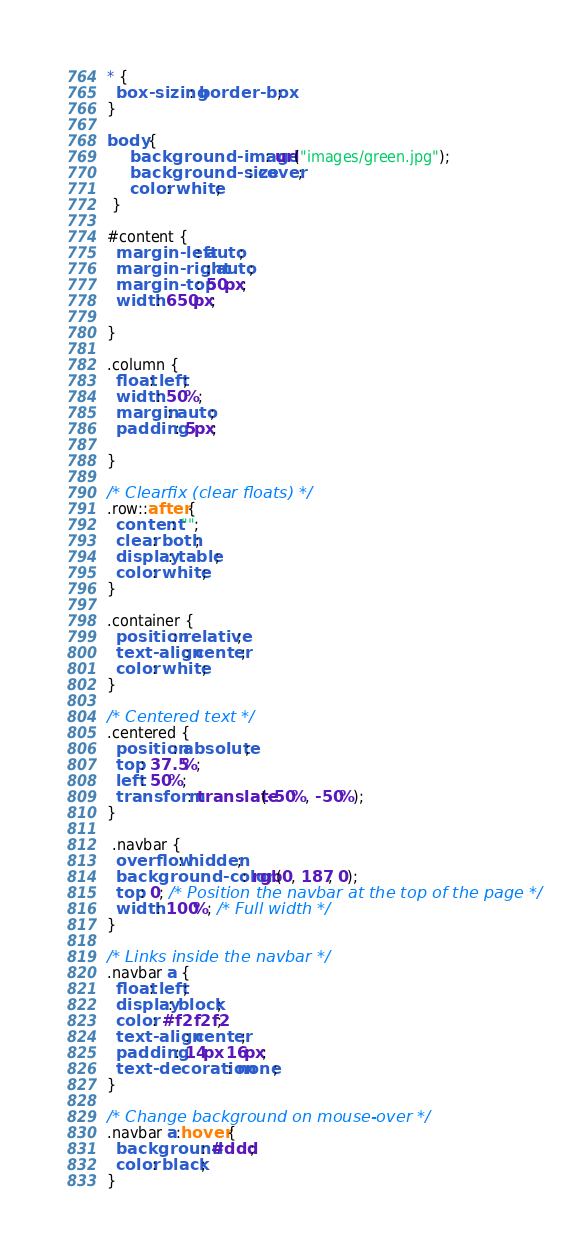Convert code to text. <code><loc_0><loc_0><loc_500><loc_500><_CSS_>* {
  box-sizing: border-box;
}

body {
     background-image: url("images/green.jpg");
     background-size: cover;
     color: white;
 }

#content {
  margin-left: auto;
  margin-right: auto;
  margin-top: 50px;
  width: 650px;
  
}

.column {
  float: left;
  width: 50%;
  margin: auto;
  padding: 5px;
  
}

/* Clearfix (clear floats) */
.row::after {
  content: "";
  clear: both;
  display: table;
  color: white;
}

.container {
  position: relative;
  text-align: center;
  color: white;
}

/* Centered text */
.centered {
  position: absolute;
  top: 37.5%;
  left: 50%;
  transform: translate(-50%, -50%);
}

 .navbar {
  overflow: hidden;
  background-color: rgb(0, 187, 0);
  top: 0; /* Position the navbar at the top of the page */
  width: 100%; /* Full width */
}

/* Links inside the navbar */
.navbar a {
  float: left;
  display: block;
  color: #f2f2f2;
  text-align: center;
  padding: 14px 16px;
  text-decoration: none;
}

/* Change background on mouse-over */
.navbar a:hover {
  background: #ddd;
  color: black;
}</code> 